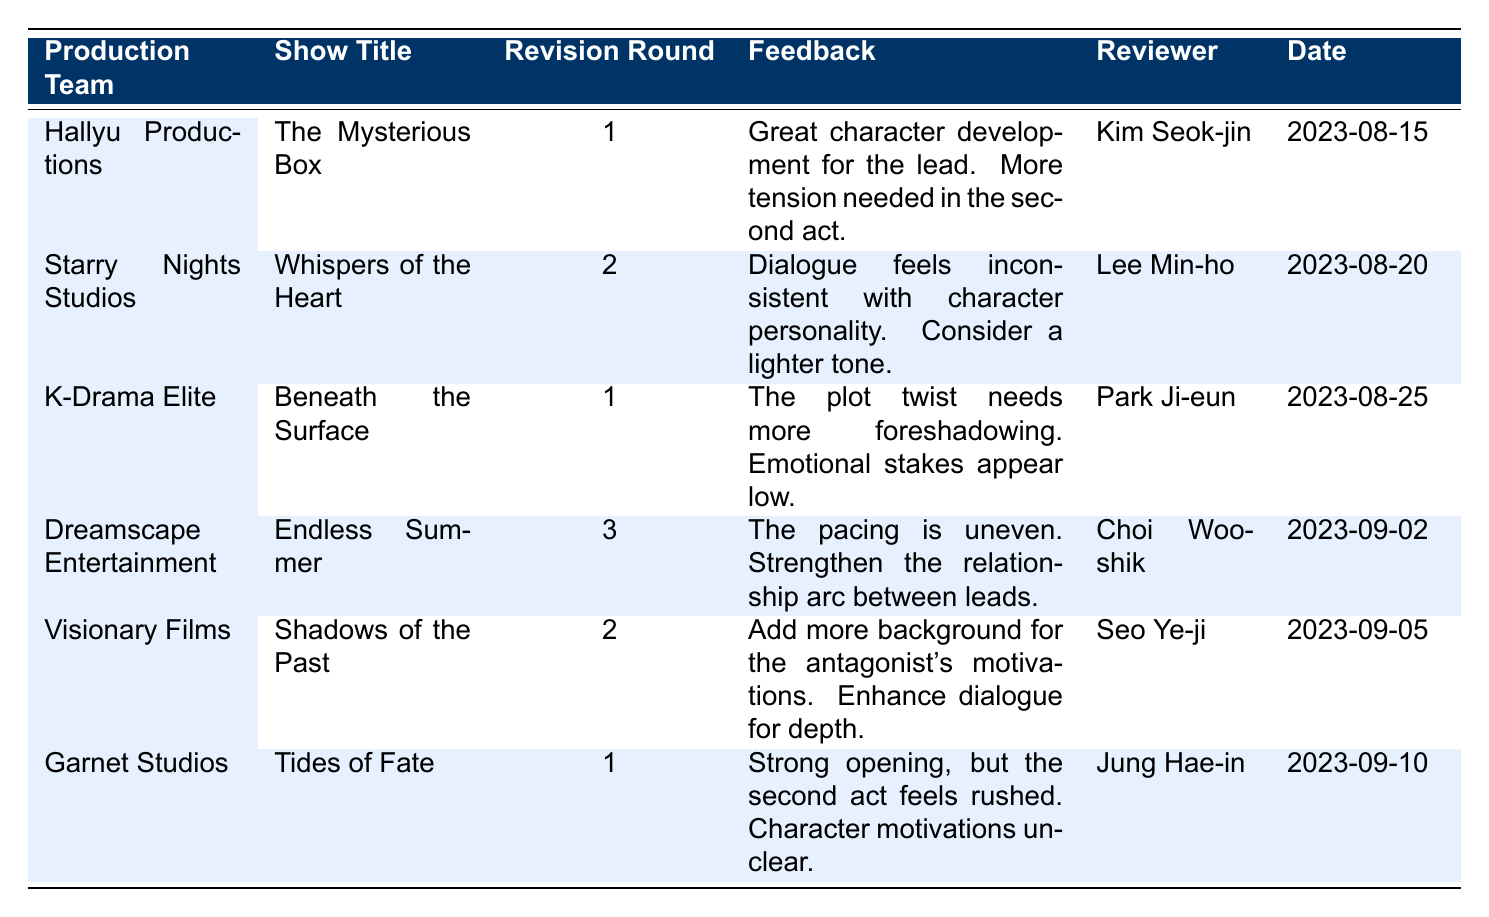What revisions were suggested by Hallyu Productions for "The Mysterious Box"? Hallyu Productions provided feedback that highlighted great character development for the lead, while also stating that more tension is needed in the second act. This information is directly available in the "Feedback" column for that specific production and show title.
Answer: Great character development for the lead. More tension needed in the second act How many different production teams provided feedback for the shows? The table contains feedback from 6 distinct production teams, which can be counted directly from the "Production Team" column of the table.
Answer: 6 Did Dreamscape Entertainment provide feedback in the first revision round? Looking at the "Revision Round" column under Dreamscape Entertainment, we see that the feedback for "Endless Summer" was provided in the 3rd revision round. Therefore, the answer is no.
Answer: No Which production team provided feedback on the second act of a show? The feedback from Hallyu Productions for "The Mysterious Box" specifically mentions needing more tension in the second act, indicating they did provide feedback related to that act.
Answer: Hallyu Productions What is the average revision round number across all shows? Adding the revision rounds (1 + 2 + 1 + 3 + 2 + 1) equals 10. There are 6 productions, so the average revision round is 10/6, which simplifies to approximately 1.67.
Answer: 1.67 Which show title received feedback from the reviewer Kim Seok-jin? Looking under the "Reviewer" column, Kim Seok-jin's feedback is associated with "The Mysterious Box" according to the "Show Title" column.
Answer: The Mysterious Box Was there a mention of character motivations in the feedback from Garnet Studios? In the feedback from Garnet Studios for "Tides of Fate," it was clearly stated that character motivations are unclear. Hence, the answer is yes.
Answer: Yes Identify the shows reviewed on September 5, 2023. In the table, looking at the "Date" column, we can see that "Shadows of the Past" from Visionary Films received feedback on September 5, 2023.
Answer: Shadows of the Past 